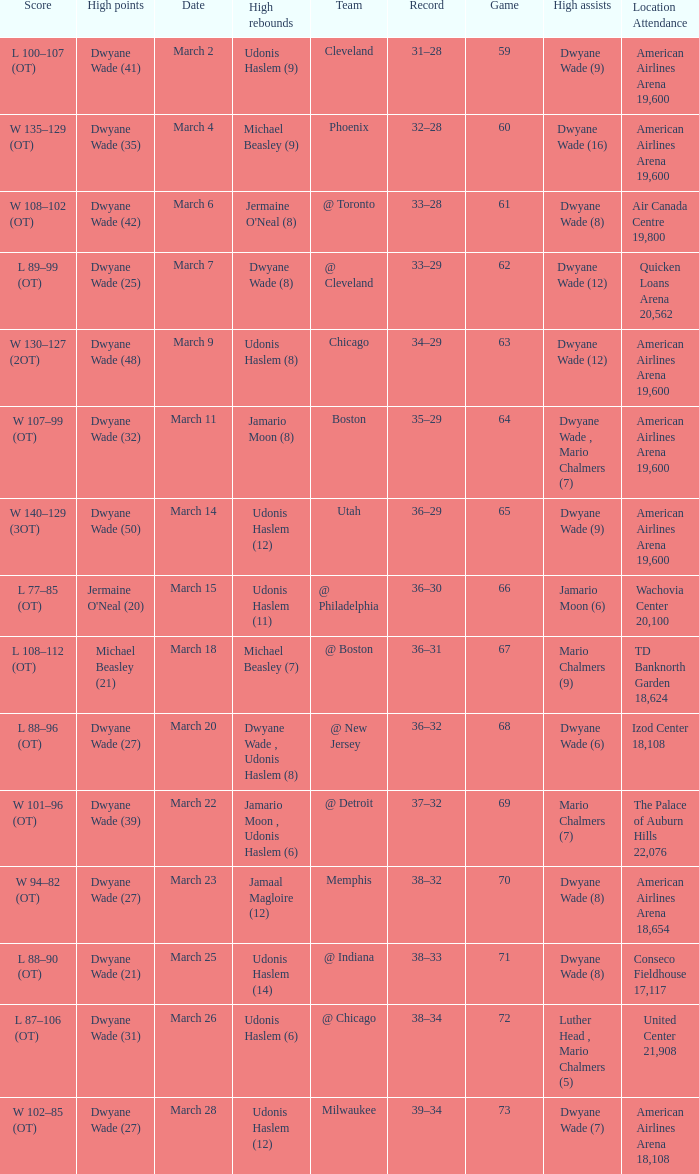Parse the table in full. {'header': ['Score', 'High points', 'Date', 'High rebounds', 'Team', 'Record', 'Game', 'High assists', 'Location Attendance'], 'rows': [['L 100–107 (OT)', 'Dwyane Wade (41)', 'March 2', 'Udonis Haslem (9)', 'Cleveland', '31–28', '59', 'Dwyane Wade (9)', 'American Airlines Arena 19,600'], ['W 135–129 (OT)', 'Dwyane Wade (35)', 'March 4', 'Michael Beasley (9)', 'Phoenix', '32–28', '60', 'Dwyane Wade (16)', 'American Airlines Arena 19,600'], ['W 108–102 (OT)', 'Dwyane Wade (42)', 'March 6', "Jermaine O'Neal (8)", '@ Toronto', '33–28', '61', 'Dwyane Wade (8)', 'Air Canada Centre 19,800'], ['L 89–99 (OT)', 'Dwyane Wade (25)', 'March 7', 'Dwyane Wade (8)', '@ Cleveland', '33–29', '62', 'Dwyane Wade (12)', 'Quicken Loans Arena 20,562'], ['W 130–127 (2OT)', 'Dwyane Wade (48)', 'March 9', 'Udonis Haslem (8)', 'Chicago', '34–29', '63', 'Dwyane Wade (12)', 'American Airlines Arena 19,600'], ['W 107–99 (OT)', 'Dwyane Wade (32)', 'March 11', 'Jamario Moon (8)', 'Boston', '35–29', '64', 'Dwyane Wade , Mario Chalmers (7)', 'American Airlines Arena 19,600'], ['W 140–129 (3OT)', 'Dwyane Wade (50)', 'March 14', 'Udonis Haslem (12)', 'Utah', '36–29', '65', 'Dwyane Wade (9)', 'American Airlines Arena 19,600'], ['L 77–85 (OT)', "Jermaine O'Neal (20)", 'March 15', 'Udonis Haslem (11)', '@ Philadelphia', '36–30', '66', 'Jamario Moon (6)', 'Wachovia Center 20,100'], ['L 108–112 (OT)', 'Michael Beasley (21)', 'March 18', 'Michael Beasley (7)', '@ Boston', '36–31', '67', 'Mario Chalmers (9)', 'TD Banknorth Garden 18,624'], ['L 88–96 (OT)', 'Dwyane Wade (27)', 'March 20', 'Dwyane Wade , Udonis Haslem (8)', '@ New Jersey', '36–32', '68', 'Dwyane Wade (6)', 'Izod Center 18,108'], ['W 101–96 (OT)', 'Dwyane Wade (39)', 'March 22', 'Jamario Moon , Udonis Haslem (6)', '@ Detroit', '37–32', '69', 'Mario Chalmers (7)', 'The Palace of Auburn Hills 22,076'], ['W 94–82 (OT)', 'Dwyane Wade (27)', 'March 23', 'Jamaal Magloire (12)', 'Memphis', '38–32', '70', 'Dwyane Wade (8)', 'American Airlines Arena 18,654'], ['L 88–90 (OT)', 'Dwyane Wade (21)', 'March 25', 'Udonis Haslem (14)', '@ Indiana', '38–33', '71', 'Dwyane Wade (8)', 'Conseco Fieldhouse 17,117'], ['L 87–106 (OT)', 'Dwyane Wade (31)', 'March 26', 'Udonis Haslem (6)', '@ Chicago', '38–34', '72', 'Luther Head , Mario Chalmers (5)', 'United Center 21,908'], ['W 102–85 (OT)', 'Dwyane Wade (27)', 'March 28', 'Udonis Haslem (12)', 'Milwaukee', '39–34', '73', 'Dwyane Wade (7)', 'American Airlines Arena 18,108']]} Who had the high point total against cleveland? Dwyane Wade (41). 